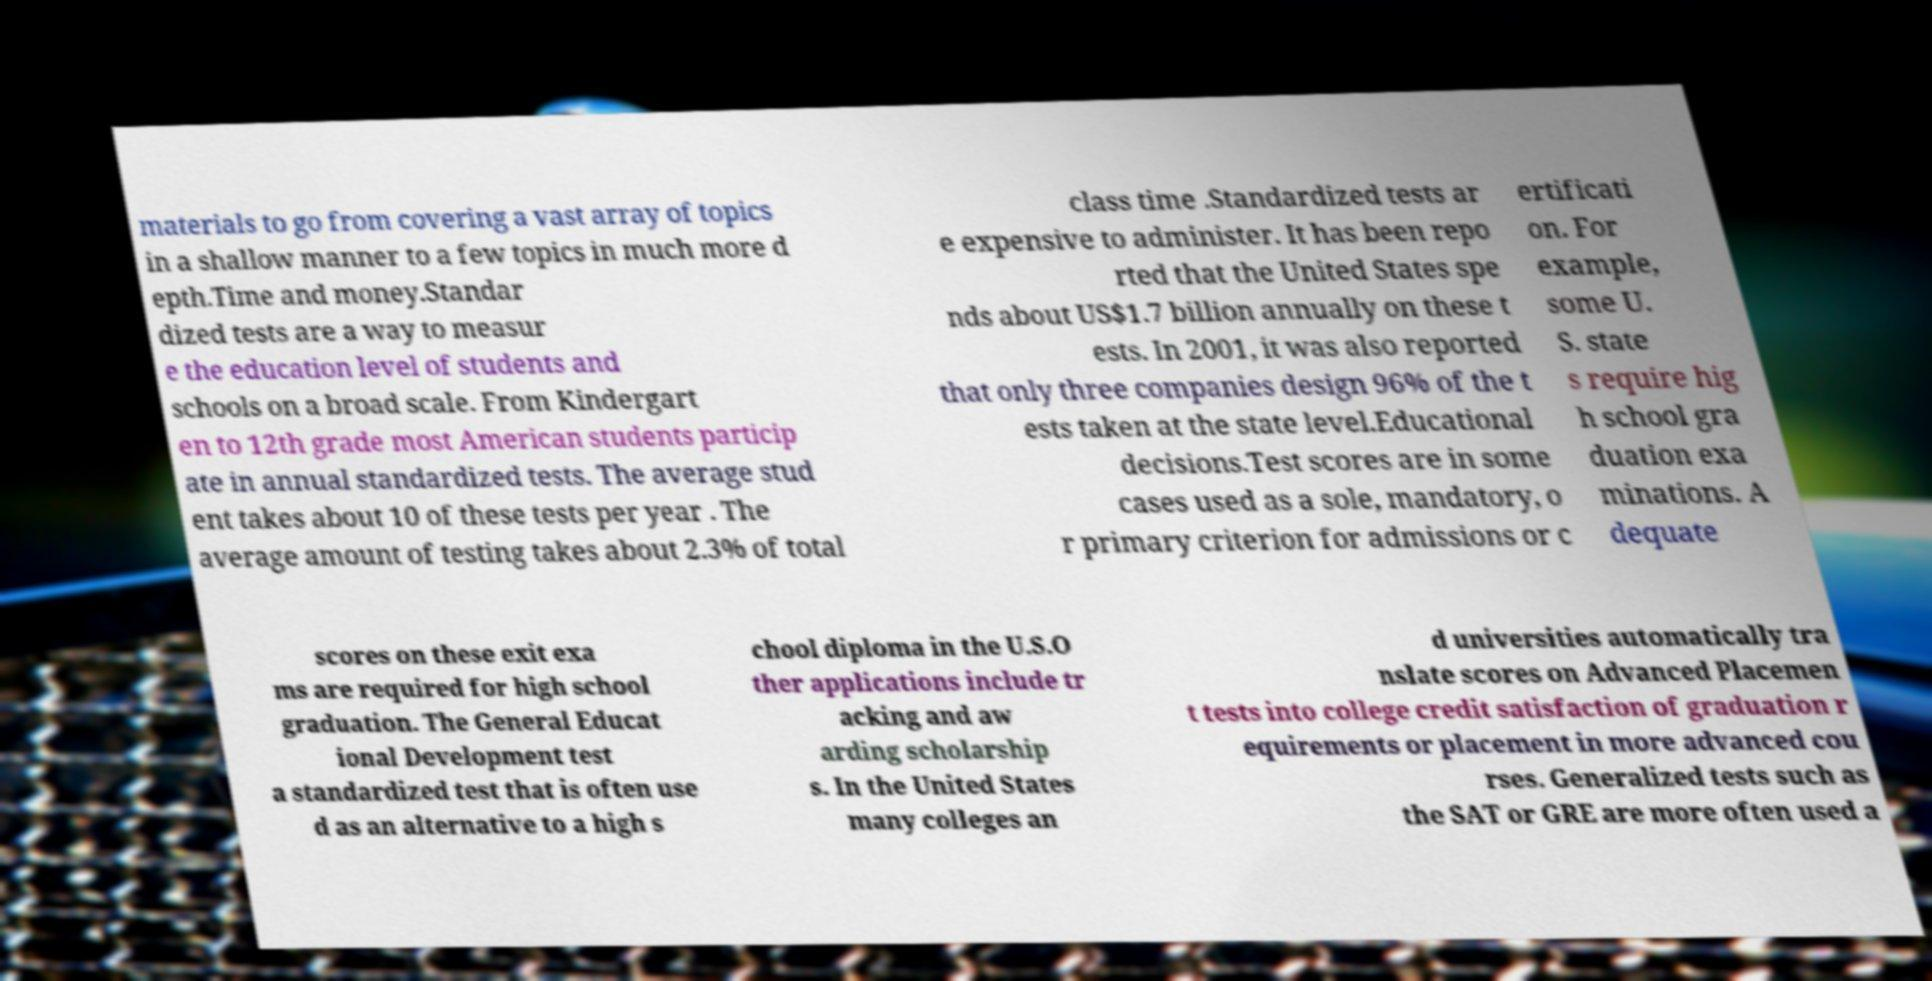Could you extract and type out the text from this image? materials to go from covering a vast array of topics in a shallow manner to a few topics in much more d epth.Time and money.Standar dized tests are a way to measur e the education level of students and schools on a broad scale. From Kindergart en to 12th grade most American students particip ate in annual standardized tests. The average stud ent takes about 10 of these tests per year . The average amount of testing takes about 2.3% of total class time .Standardized tests ar e expensive to administer. It has been repo rted that the United States spe nds about US$1.7 billion annually on these t ests. In 2001, it was also reported that only three companies design 96% of the t ests taken at the state level.Educational decisions.Test scores are in some cases used as a sole, mandatory, o r primary criterion for admissions or c ertificati on. For example, some U. S. state s require hig h school gra duation exa minations. A dequate scores on these exit exa ms are required for high school graduation. The General Educat ional Development test a standardized test that is often use d as an alternative to a high s chool diploma in the U.S.O ther applications include tr acking and aw arding scholarship s. In the United States many colleges an d universities automatically tra nslate scores on Advanced Placemen t tests into college credit satisfaction of graduation r equirements or placement in more advanced cou rses. Generalized tests such as the SAT or GRE are more often used a 